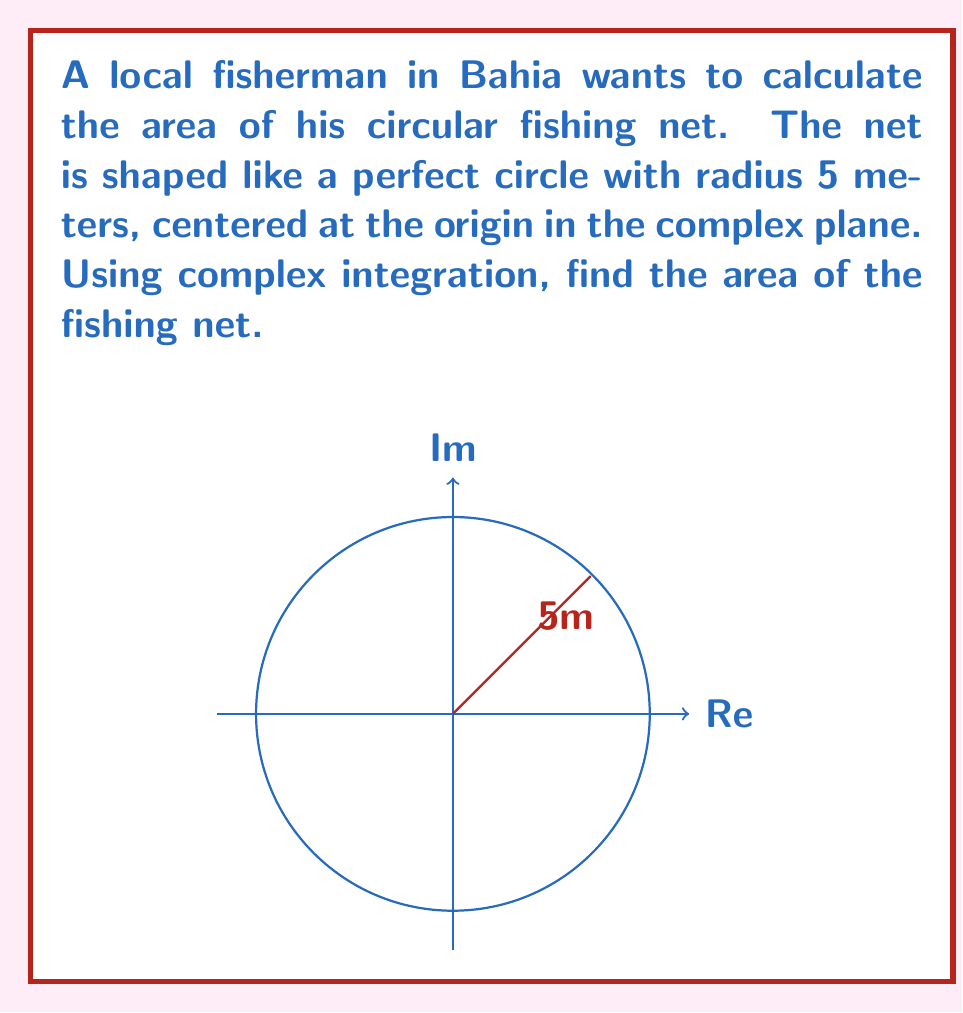What is the answer to this math problem? Let's approach this step-by-step using complex integration:

1) The area of a region in the complex plane can be calculated using the formula:

   $$A = -\frac{1}{2i} \oint_C z d\bar{z}$$

   where $C$ is the boundary of the region.

2) For a circle centered at the origin with radius $r$, we can parametrize it as:

   $$z = re^{i\theta}, \quad 0 \leq \theta \leq 2\pi$$

3) Then, $\bar{z} = re^{-i\theta}$ and $d\bar{z} = -ire^{-i\theta}d\theta$

4) Substituting into our integral:

   $$A = -\frac{1}{2i} \int_0^{2\pi} re^{i\theta} (-ire^{-i\theta}) d\theta$$

5) Simplifying:

   $$A = \frac{r^2}{2} \int_0^{2\pi} d\theta$$

6) Evaluating the integral:

   $$A = \frac{r^2}{2} [2\pi]$$

7) Therefore, the area is:

   $$A = \pi r^2$$

8) In this case, $r = 5$ meters, so:

   $$A = \pi (5)^2 = 25\pi$$

Thus, the area of the fishing net is $25\pi$ square meters.
Answer: $25\pi$ square meters 